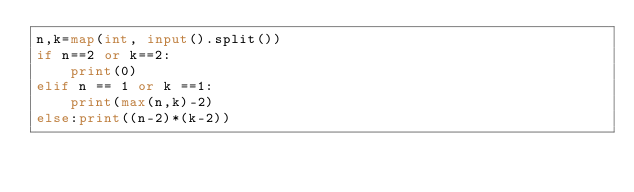Convert code to text. <code><loc_0><loc_0><loc_500><loc_500><_Python_>n,k=map(int, input().split())
if n==2 or k==2:
    print(0)
elif n == 1 or k ==1:
    print(max(n,k)-2)
else:print((n-2)*(k-2))</code> 